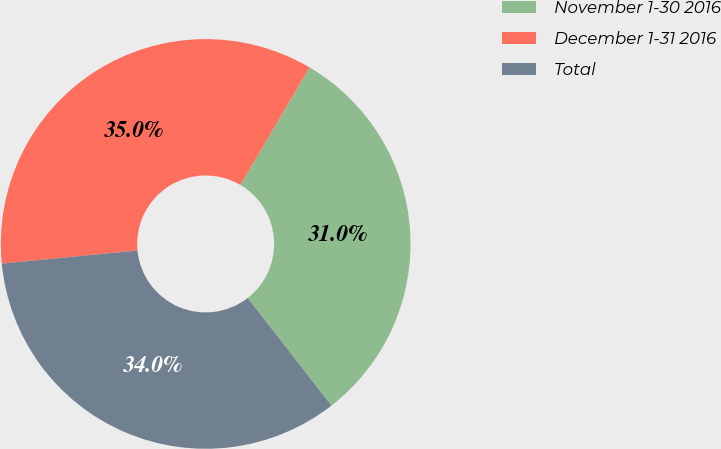Convert chart. <chart><loc_0><loc_0><loc_500><loc_500><pie_chart><fcel>November 1-30 2016<fcel>December 1-31 2016<fcel>Total<nl><fcel>31.01%<fcel>35.0%<fcel>33.99%<nl></chart> 